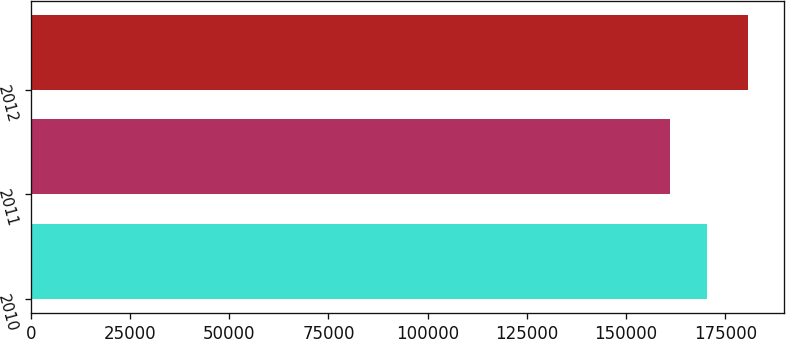Convert chart. <chart><loc_0><loc_0><loc_500><loc_500><bar_chart><fcel>2010<fcel>2011<fcel>2012<nl><fcel>170274<fcel>161073<fcel>180616<nl></chart> 